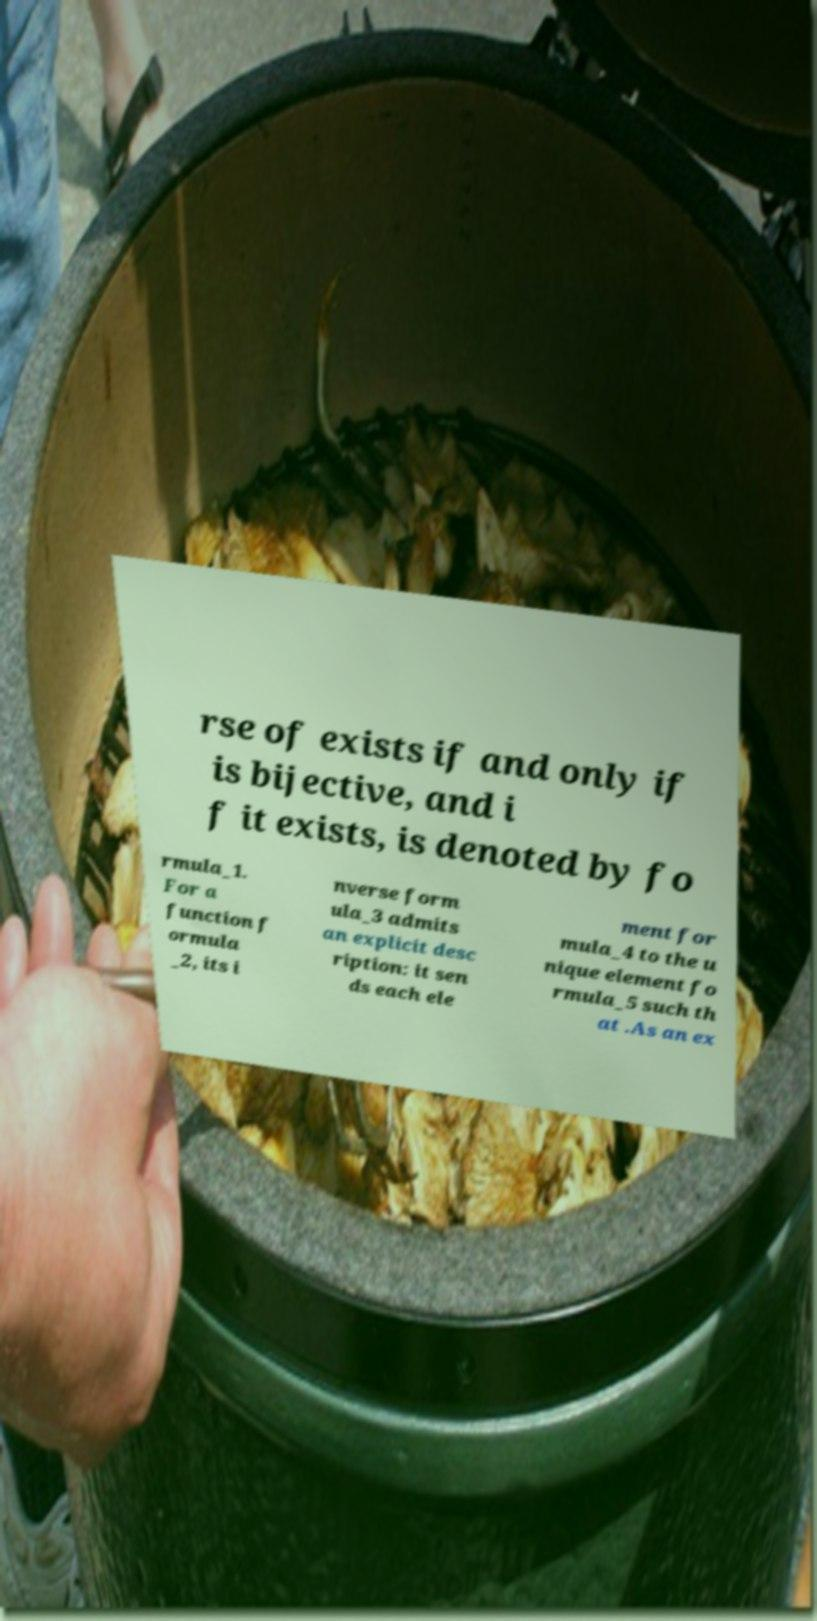I need the written content from this picture converted into text. Can you do that? rse of exists if and only if is bijective, and i f it exists, is denoted by fo rmula_1. For a function f ormula _2, its i nverse form ula_3 admits an explicit desc ription: it sen ds each ele ment for mula_4 to the u nique element fo rmula_5 such th at .As an ex 